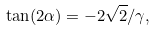<formula> <loc_0><loc_0><loc_500><loc_500>\tan ( 2 \alpha ) = - 2 \sqrt { 2 } / \gamma ,</formula> 